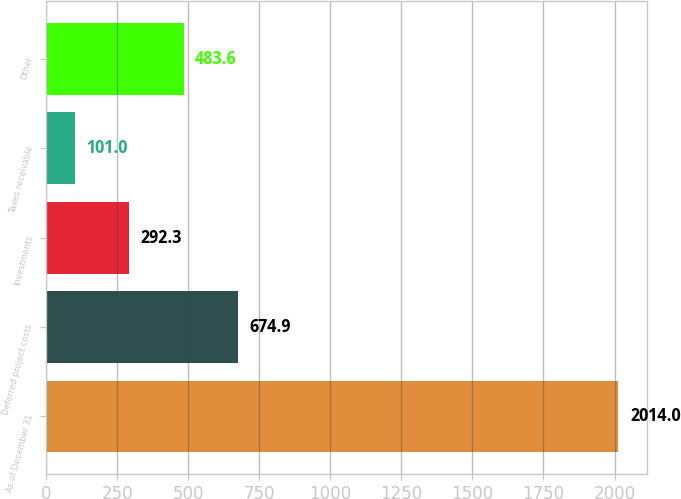Convert chart to OTSL. <chart><loc_0><loc_0><loc_500><loc_500><bar_chart><fcel>As of December 31<fcel>Deferred project costs<fcel>Investments<fcel>Taxes receivable<fcel>Other<nl><fcel>2014<fcel>674.9<fcel>292.3<fcel>101<fcel>483.6<nl></chart> 